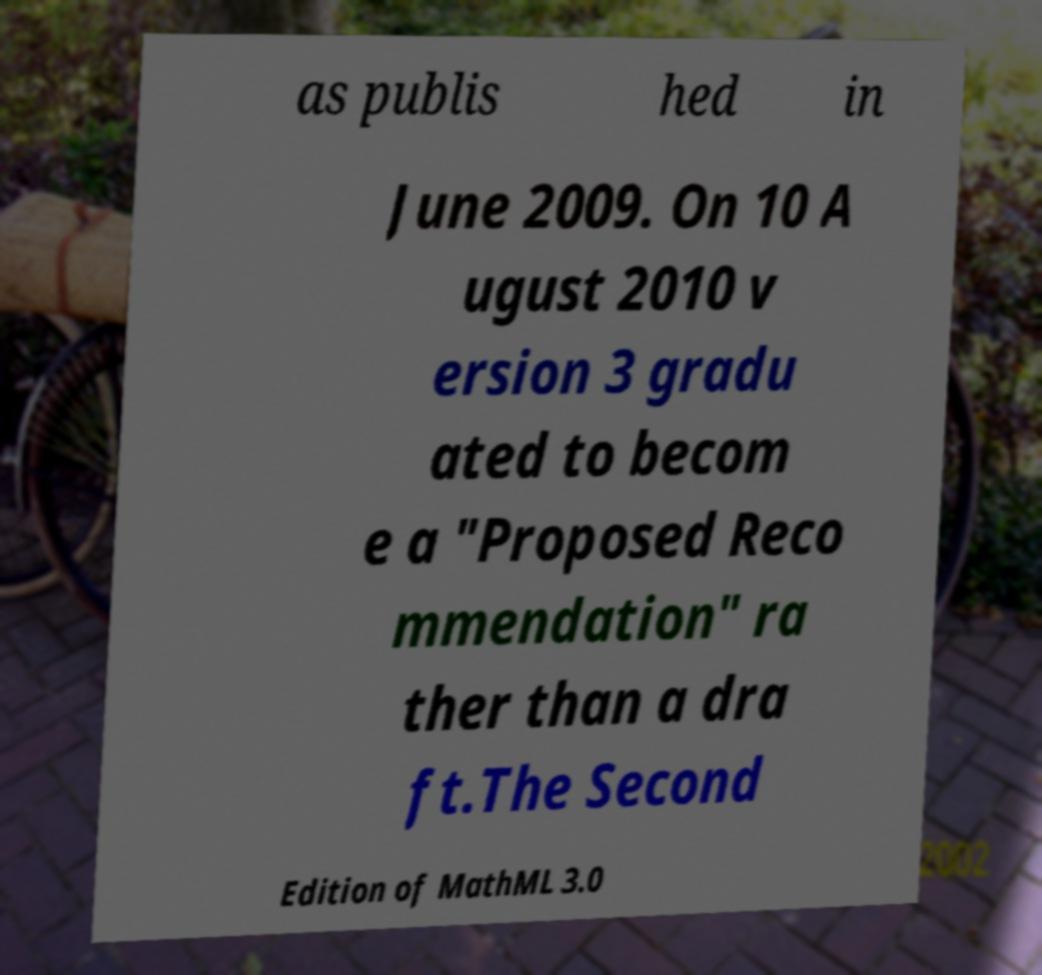For documentation purposes, I need the text within this image transcribed. Could you provide that? as publis hed in June 2009. On 10 A ugust 2010 v ersion 3 gradu ated to becom e a "Proposed Reco mmendation" ra ther than a dra ft.The Second Edition of MathML 3.0 